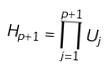<formula> <loc_0><loc_0><loc_500><loc_500>H _ { p + 1 } = \prod _ { j = 1 } ^ { p + 1 } U _ { j }</formula> 